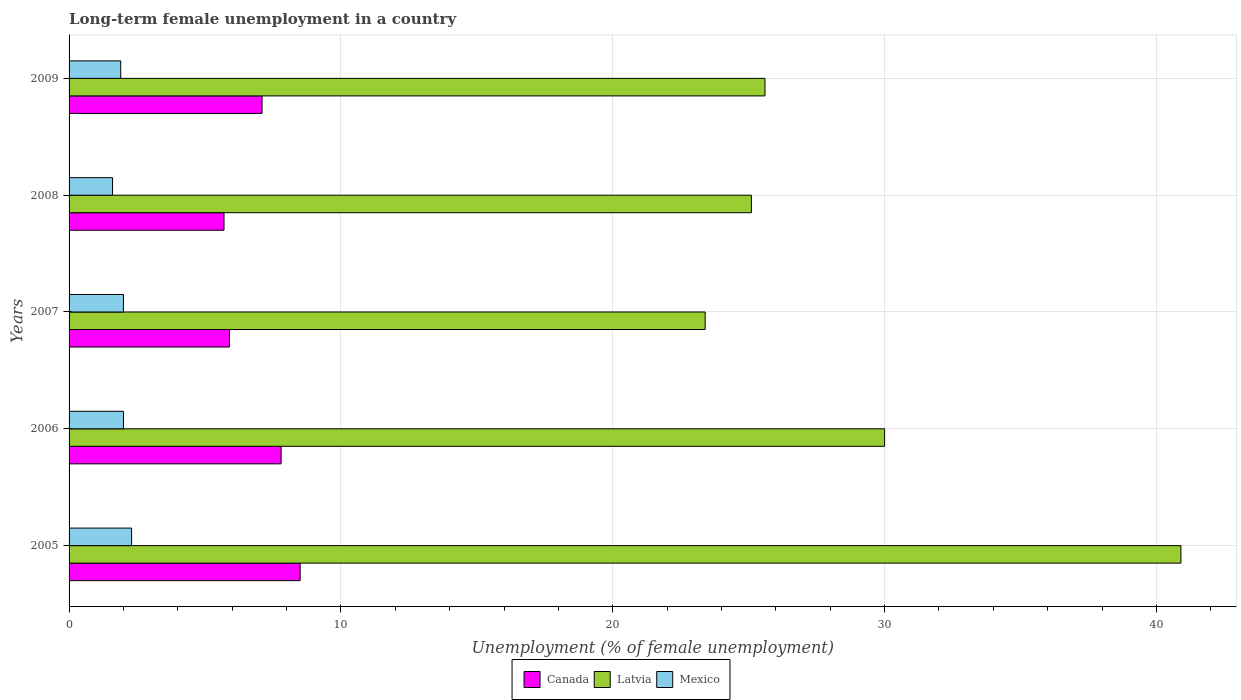Are the number of bars per tick equal to the number of legend labels?
Make the answer very short. Yes. How many bars are there on the 2nd tick from the top?
Keep it short and to the point. 3. How many bars are there on the 4th tick from the bottom?
Your response must be concise. 3. What is the label of the 1st group of bars from the top?
Your response must be concise. 2009. In how many cases, is the number of bars for a given year not equal to the number of legend labels?
Offer a very short reply. 0. Across all years, what is the maximum percentage of long-term unemployed female population in Mexico?
Keep it short and to the point. 2.3. Across all years, what is the minimum percentage of long-term unemployed female population in Mexico?
Offer a terse response. 1.6. In which year was the percentage of long-term unemployed female population in Mexico maximum?
Your answer should be compact. 2005. What is the difference between the percentage of long-term unemployed female population in Latvia in 2005 and that in 2007?
Your response must be concise. 17.5. What is the difference between the percentage of long-term unemployed female population in Mexico in 2006 and the percentage of long-term unemployed female population in Latvia in 2009?
Provide a succinct answer. -23.6. What is the average percentage of long-term unemployed female population in Canada per year?
Provide a short and direct response. 7. In the year 2007, what is the difference between the percentage of long-term unemployed female population in Mexico and percentage of long-term unemployed female population in Latvia?
Your response must be concise. -21.4. What is the ratio of the percentage of long-term unemployed female population in Canada in 2008 to that in 2009?
Your response must be concise. 0.8. Is the difference between the percentage of long-term unemployed female population in Mexico in 2006 and 2008 greater than the difference between the percentage of long-term unemployed female population in Latvia in 2006 and 2008?
Keep it short and to the point. No. What is the difference between the highest and the second highest percentage of long-term unemployed female population in Canada?
Ensure brevity in your answer.  0.7. What is the difference between the highest and the lowest percentage of long-term unemployed female population in Mexico?
Your response must be concise. 0.7. In how many years, is the percentage of long-term unemployed female population in Canada greater than the average percentage of long-term unemployed female population in Canada taken over all years?
Offer a terse response. 3. Is the sum of the percentage of long-term unemployed female population in Canada in 2005 and 2009 greater than the maximum percentage of long-term unemployed female population in Mexico across all years?
Your answer should be compact. Yes. What does the 1st bar from the top in 2005 represents?
Provide a short and direct response. Mexico. What does the 2nd bar from the bottom in 2009 represents?
Provide a succinct answer. Latvia. How many bars are there?
Your answer should be very brief. 15. Are all the bars in the graph horizontal?
Give a very brief answer. Yes. Are the values on the major ticks of X-axis written in scientific E-notation?
Make the answer very short. No. What is the title of the graph?
Keep it short and to the point. Long-term female unemployment in a country. Does "Lebanon" appear as one of the legend labels in the graph?
Make the answer very short. No. What is the label or title of the X-axis?
Give a very brief answer. Unemployment (% of female unemployment). What is the Unemployment (% of female unemployment) of Canada in 2005?
Make the answer very short. 8.5. What is the Unemployment (% of female unemployment) in Latvia in 2005?
Provide a succinct answer. 40.9. What is the Unemployment (% of female unemployment) of Mexico in 2005?
Provide a succinct answer. 2.3. What is the Unemployment (% of female unemployment) of Canada in 2006?
Make the answer very short. 7.8. What is the Unemployment (% of female unemployment) in Canada in 2007?
Give a very brief answer. 5.9. What is the Unemployment (% of female unemployment) of Latvia in 2007?
Make the answer very short. 23.4. What is the Unemployment (% of female unemployment) in Mexico in 2007?
Your answer should be compact. 2. What is the Unemployment (% of female unemployment) of Canada in 2008?
Provide a short and direct response. 5.7. What is the Unemployment (% of female unemployment) in Latvia in 2008?
Offer a terse response. 25.1. What is the Unemployment (% of female unemployment) of Mexico in 2008?
Your response must be concise. 1.6. What is the Unemployment (% of female unemployment) in Canada in 2009?
Make the answer very short. 7.1. What is the Unemployment (% of female unemployment) of Latvia in 2009?
Provide a short and direct response. 25.6. What is the Unemployment (% of female unemployment) in Mexico in 2009?
Provide a succinct answer. 1.9. Across all years, what is the maximum Unemployment (% of female unemployment) of Canada?
Provide a succinct answer. 8.5. Across all years, what is the maximum Unemployment (% of female unemployment) of Latvia?
Make the answer very short. 40.9. Across all years, what is the maximum Unemployment (% of female unemployment) of Mexico?
Your response must be concise. 2.3. Across all years, what is the minimum Unemployment (% of female unemployment) of Canada?
Ensure brevity in your answer.  5.7. Across all years, what is the minimum Unemployment (% of female unemployment) of Latvia?
Provide a succinct answer. 23.4. Across all years, what is the minimum Unemployment (% of female unemployment) in Mexico?
Offer a terse response. 1.6. What is the total Unemployment (% of female unemployment) in Canada in the graph?
Give a very brief answer. 35. What is the total Unemployment (% of female unemployment) of Latvia in the graph?
Keep it short and to the point. 145. What is the total Unemployment (% of female unemployment) of Mexico in the graph?
Ensure brevity in your answer.  9.8. What is the difference between the Unemployment (% of female unemployment) in Latvia in 2005 and that in 2008?
Give a very brief answer. 15.8. What is the difference between the Unemployment (% of female unemployment) of Canada in 2005 and that in 2009?
Make the answer very short. 1.4. What is the difference between the Unemployment (% of female unemployment) in Latvia in 2006 and that in 2007?
Make the answer very short. 6.6. What is the difference between the Unemployment (% of female unemployment) of Mexico in 2006 and that in 2007?
Keep it short and to the point. 0. What is the difference between the Unemployment (% of female unemployment) in Canada in 2006 and that in 2008?
Ensure brevity in your answer.  2.1. What is the difference between the Unemployment (% of female unemployment) of Canada in 2006 and that in 2009?
Keep it short and to the point. 0.7. What is the difference between the Unemployment (% of female unemployment) of Latvia in 2006 and that in 2009?
Provide a short and direct response. 4.4. What is the difference between the Unemployment (% of female unemployment) of Mexico in 2007 and that in 2008?
Offer a terse response. 0.4. What is the difference between the Unemployment (% of female unemployment) of Mexico in 2007 and that in 2009?
Ensure brevity in your answer.  0.1. What is the difference between the Unemployment (% of female unemployment) in Mexico in 2008 and that in 2009?
Provide a short and direct response. -0.3. What is the difference between the Unemployment (% of female unemployment) in Canada in 2005 and the Unemployment (% of female unemployment) in Latvia in 2006?
Your answer should be very brief. -21.5. What is the difference between the Unemployment (% of female unemployment) in Canada in 2005 and the Unemployment (% of female unemployment) in Mexico in 2006?
Give a very brief answer. 6.5. What is the difference between the Unemployment (% of female unemployment) of Latvia in 2005 and the Unemployment (% of female unemployment) of Mexico in 2006?
Provide a succinct answer. 38.9. What is the difference between the Unemployment (% of female unemployment) of Canada in 2005 and the Unemployment (% of female unemployment) of Latvia in 2007?
Offer a very short reply. -14.9. What is the difference between the Unemployment (% of female unemployment) of Latvia in 2005 and the Unemployment (% of female unemployment) of Mexico in 2007?
Your response must be concise. 38.9. What is the difference between the Unemployment (% of female unemployment) in Canada in 2005 and the Unemployment (% of female unemployment) in Latvia in 2008?
Ensure brevity in your answer.  -16.6. What is the difference between the Unemployment (% of female unemployment) in Canada in 2005 and the Unemployment (% of female unemployment) in Mexico in 2008?
Give a very brief answer. 6.9. What is the difference between the Unemployment (% of female unemployment) in Latvia in 2005 and the Unemployment (% of female unemployment) in Mexico in 2008?
Provide a succinct answer. 39.3. What is the difference between the Unemployment (% of female unemployment) in Canada in 2005 and the Unemployment (% of female unemployment) in Latvia in 2009?
Keep it short and to the point. -17.1. What is the difference between the Unemployment (% of female unemployment) of Latvia in 2005 and the Unemployment (% of female unemployment) of Mexico in 2009?
Your answer should be very brief. 39. What is the difference between the Unemployment (% of female unemployment) in Canada in 2006 and the Unemployment (% of female unemployment) in Latvia in 2007?
Give a very brief answer. -15.6. What is the difference between the Unemployment (% of female unemployment) in Canada in 2006 and the Unemployment (% of female unemployment) in Latvia in 2008?
Offer a terse response. -17.3. What is the difference between the Unemployment (% of female unemployment) of Canada in 2006 and the Unemployment (% of female unemployment) of Mexico in 2008?
Provide a short and direct response. 6.2. What is the difference between the Unemployment (% of female unemployment) in Latvia in 2006 and the Unemployment (% of female unemployment) in Mexico in 2008?
Your answer should be very brief. 28.4. What is the difference between the Unemployment (% of female unemployment) of Canada in 2006 and the Unemployment (% of female unemployment) of Latvia in 2009?
Provide a short and direct response. -17.8. What is the difference between the Unemployment (% of female unemployment) of Latvia in 2006 and the Unemployment (% of female unemployment) of Mexico in 2009?
Your response must be concise. 28.1. What is the difference between the Unemployment (% of female unemployment) in Canada in 2007 and the Unemployment (% of female unemployment) in Latvia in 2008?
Give a very brief answer. -19.2. What is the difference between the Unemployment (% of female unemployment) in Canada in 2007 and the Unemployment (% of female unemployment) in Mexico in 2008?
Provide a succinct answer. 4.3. What is the difference between the Unemployment (% of female unemployment) of Latvia in 2007 and the Unemployment (% of female unemployment) of Mexico in 2008?
Offer a terse response. 21.8. What is the difference between the Unemployment (% of female unemployment) of Canada in 2007 and the Unemployment (% of female unemployment) of Latvia in 2009?
Your answer should be very brief. -19.7. What is the difference between the Unemployment (% of female unemployment) in Latvia in 2007 and the Unemployment (% of female unemployment) in Mexico in 2009?
Your response must be concise. 21.5. What is the difference between the Unemployment (% of female unemployment) in Canada in 2008 and the Unemployment (% of female unemployment) in Latvia in 2009?
Offer a terse response. -19.9. What is the difference between the Unemployment (% of female unemployment) of Latvia in 2008 and the Unemployment (% of female unemployment) of Mexico in 2009?
Keep it short and to the point. 23.2. What is the average Unemployment (% of female unemployment) of Canada per year?
Offer a terse response. 7. What is the average Unemployment (% of female unemployment) of Mexico per year?
Your answer should be compact. 1.96. In the year 2005, what is the difference between the Unemployment (% of female unemployment) of Canada and Unemployment (% of female unemployment) of Latvia?
Ensure brevity in your answer.  -32.4. In the year 2005, what is the difference between the Unemployment (% of female unemployment) of Canada and Unemployment (% of female unemployment) of Mexico?
Give a very brief answer. 6.2. In the year 2005, what is the difference between the Unemployment (% of female unemployment) in Latvia and Unemployment (% of female unemployment) in Mexico?
Provide a short and direct response. 38.6. In the year 2006, what is the difference between the Unemployment (% of female unemployment) of Canada and Unemployment (% of female unemployment) of Latvia?
Your answer should be compact. -22.2. In the year 2006, what is the difference between the Unemployment (% of female unemployment) of Canada and Unemployment (% of female unemployment) of Mexico?
Keep it short and to the point. 5.8. In the year 2007, what is the difference between the Unemployment (% of female unemployment) of Canada and Unemployment (% of female unemployment) of Latvia?
Give a very brief answer. -17.5. In the year 2007, what is the difference between the Unemployment (% of female unemployment) in Canada and Unemployment (% of female unemployment) in Mexico?
Your answer should be very brief. 3.9. In the year 2007, what is the difference between the Unemployment (% of female unemployment) of Latvia and Unemployment (% of female unemployment) of Mexico?
Make the answer very short. 21.4. In the year 2008, what is the difference between the Unemployment (% of female unemployment) of Canada and Unemployment (% of female unemployment) of Latvia?
Give a very brief answer. -19.4. In the year 2008, what is the difference between the Unemployment (% of female unemployment) in Latvia and Unemployment (% of female unemployment) in Mexico?
Provide a succinct answer. 23.5. In the year 2009, what is the difference between the Unemployment (% of female unemployment) of Canada and Unemployment (% of female unemployment) of Latvia?
Give a very brief answer. -18.5. In the year 2009, what is the difference between the Unemployment (% of female unemployment) in Canada and Unemployment (% of female unemployment) in Mexico?
Give a very brief answer. 5.2. In the year 2009, what is the difference between the Unemployment (% of female unemployment) of Latvia and Unemployment (% of female unemployment) of Mexico?
Give a very brief answer. 23.7. What is the ratio of the Unemployment (% of female unemployment) of Canada in 2005 to that in 2006?
Your answer should be compact. 1.09. What is the ratio of the Unemployment (% of female unemployment) of Latvia in 2005 to that in 2006?
Make the answer very short. 1.36. What is the ratio of the Unemployment (% of female unemployment) in Mexico in 2005 to that in 2006?
Give a very brief answer. 1.15. What is the ratio of the Unemployment (% of female unemployment) of Canada in 2005 to that in 2007?
Your answer should be compact. 1.44. What is the ratio of the Unemployment (% of female unemployment) in Latvia in 2005 to that in 2007?
Ensure brevity in your answer.  1.75. What is the ratio of the Unemployment (% of female unemployment) in Mexico in 2005 to that in 2007?
Offer a terse response. 1.15. What is the ratio of the Unemployment (% of female unemployment) in Canada in 2005 to that in 2008?
Your response must be concise. 1.49. What is the ratio of the Unemployment (% of female unemployment) of Latvia in 2005 to that in 2008?
Your answer should be compact. 1.63. What is the ratio of the Unemployment (% of female unemployment) in Mexico in 2005 to that in 2008?
Your answer should be very brief. 1.44. What is the ratio of the Unemployment (% of female unemployment) of Canada in 2005 to that in 2009?
Provide a succinct answer. 1.2. What is the ratio of the Unemployment (% of female unemployment) in Latvia in 2005 to that in 2009?
Make the answer very short. 1.6. What is the ratio of the Unemployment (% of female unemployment) in Mexico in 2005 to that in 2009?
Your answer should be compact. 1.21. What is the ratio of the Unemployment (% of female unemployment) in Canada in 2006 to that in 2007?
Provide a succinct answer. 1.32. What is the ratio of the Unemployment (% of female unemployment) of Latvia in 2006 to that in 2007?
Provide a succinct answer. 1.28. What is the ratio of the Unemployment (% of female unemployment) in Canada in 2006 to that in 2008?
Offer a terse response. 1.37. What is the ratio of the Unemployment (% of female unemployment) in Latvia in 2006 to that in 2008?
Provide a short and direct response. 1.2. What is the ratio of the Unemployment (% of female unemployment) in Canada in 2006 to that in 2009?
Offer a very short reply. 1.1. What is the ratio of the Unemployment (% of female unemployment) in Latvia in 2006 to that in 2009?
Provide a succinct answer. 1.17. What is the ratio of the Unemployment (% of female unemployment) of Mexico in 2006 to that in 2009?
Your response must be concise. 1.05. What is the ratio of the Unemployment (% of female unemployment) in Canada in 2007 to that in 2008?
Offer a terse response. 1.04. What is the ratio of the Unemployment (% of female unemployment) of Latvia in 2007 to that in 2008?
Provide a short and direct response. 0.93. What is the ratio of the Unemployment (% of female unemployment) of Mexico in 2007 to that in 2008?
Your answer should be very brief. 1.25. What is the ratio of the Unemployment (% of female unemployment) of Canada in 2007 to that in 2009?
Provide a succinct answer. 0.83. What is the ratio of the Unemployment (% of female unemployment) in Latvia in 2007 to that in 2009?
Your response must be concise. 0.91. What is the ratio of the Unemployment (% of female unemployment) of Mexico in 2007 to that in 2009?
Offer a very short reply. 1.05. What is the ratio of the Unemployment (% of female unemployment) in Canada in 2008 to that in 2009?
Provide a short and direct response. 0.8. What is the ratio of the Unemployment (% of female unemployment) in Latvia in 2008 to that in 2009?
Offer a terse response. 0.98. What is the ratio of the Unemployment (% of female unemployment) in Mexico in 2008 to that in 2009?
Your response must be concise. 0.84. What is the difference between the highest and the second highest Unemployment (% of female unemployment) of Latvia?
Offer a very short reply. 10.9. What is the difference between the highest and the lowest Unemployment (% of female unemployment) in Latvia?
Provide a short and direct response. 17.5. 